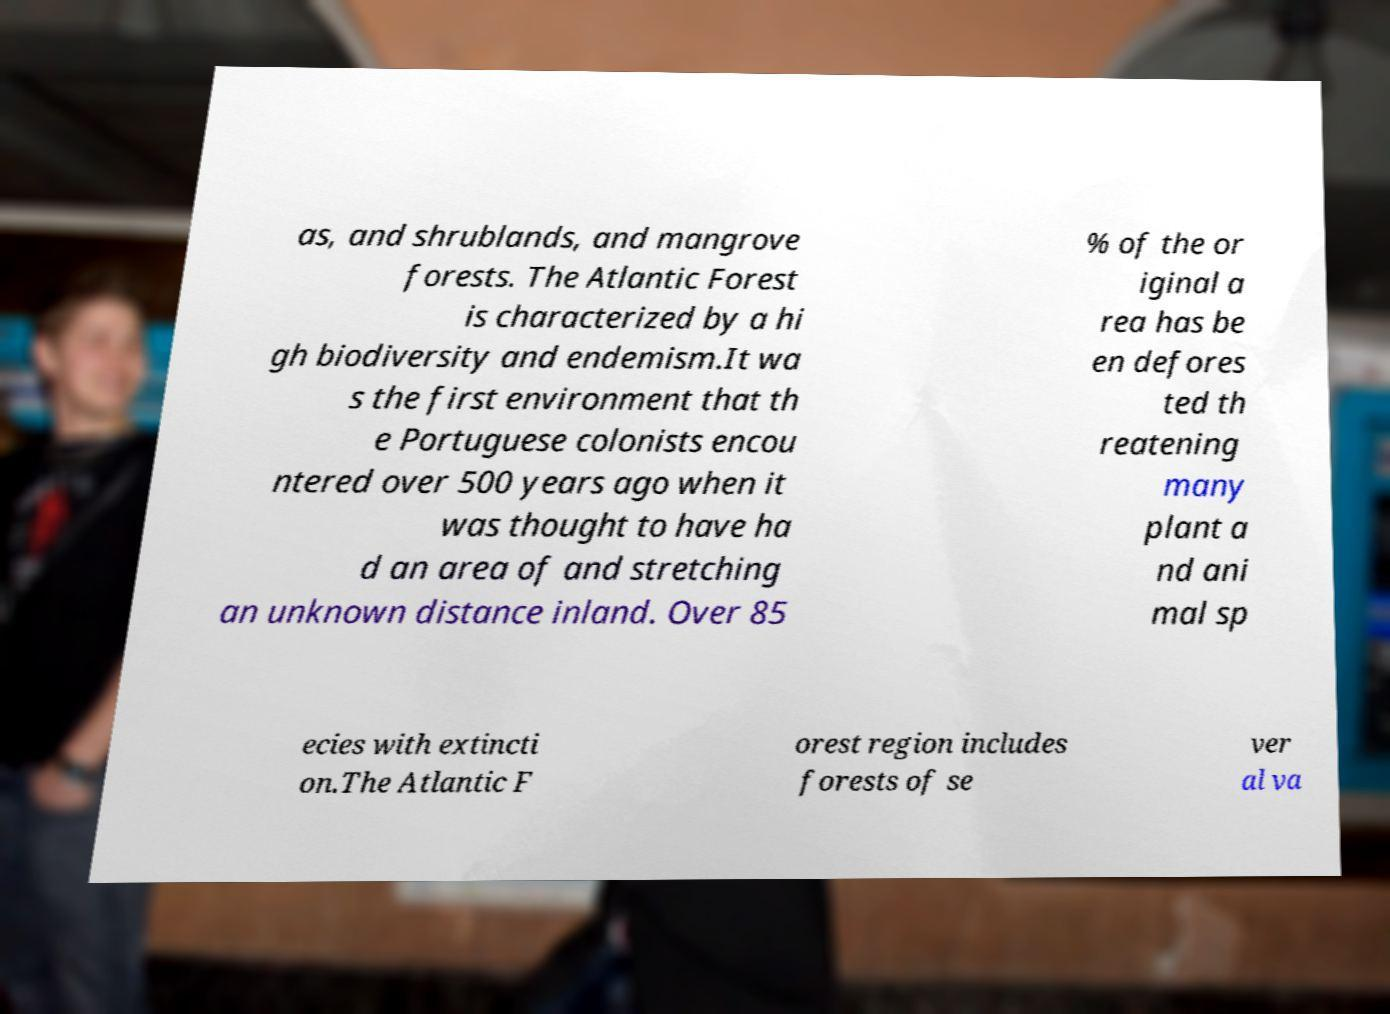For documentation purposes, I need the text within this image transcribed. Could you provide that? as, and shrublands, and mangrove forests. The Atlantic Forest is characterized by a hi gh biodiversity and endemism.It wa s the first environment that th e Portuguese colonists encou ntered over 500 years ago when it was thought to have ha d an area of and stretching an unknown distance inland. Over 85 % of the or iginal a rea has be en defores ted th reatening many plant a nd ani mal sp ecies with extincti on.The Atlantic F orest region includes forests of se ver al va 